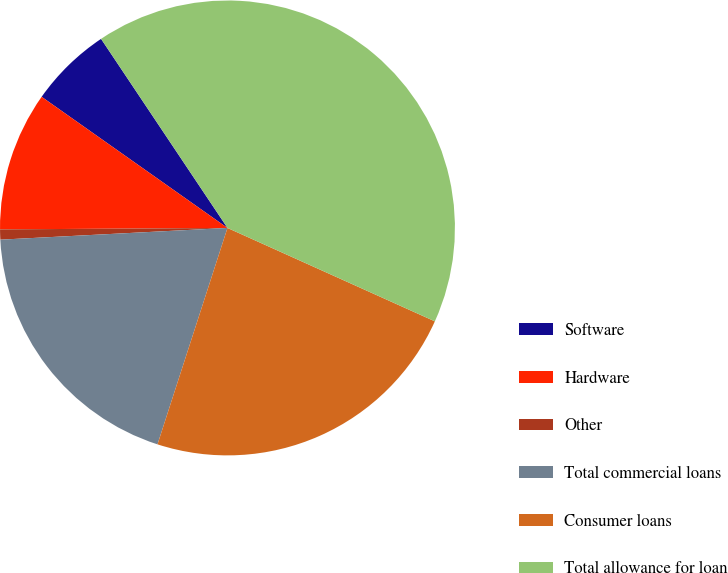Convert chart. <chart><loc_0><loc_0><loc_500><loc_500><pie_chart><fcel>Software<fcel>Hardware<fcel>Other<fcel>Total commercial loans<fcel>Consumer loans<fcel>Total allowance for loan<nl><fcel>5.84%<fcel>9.88%<fcel>0.72%<fcel>19.2%<fcel>23.24%<fcel>41.11%<nl></chart> 